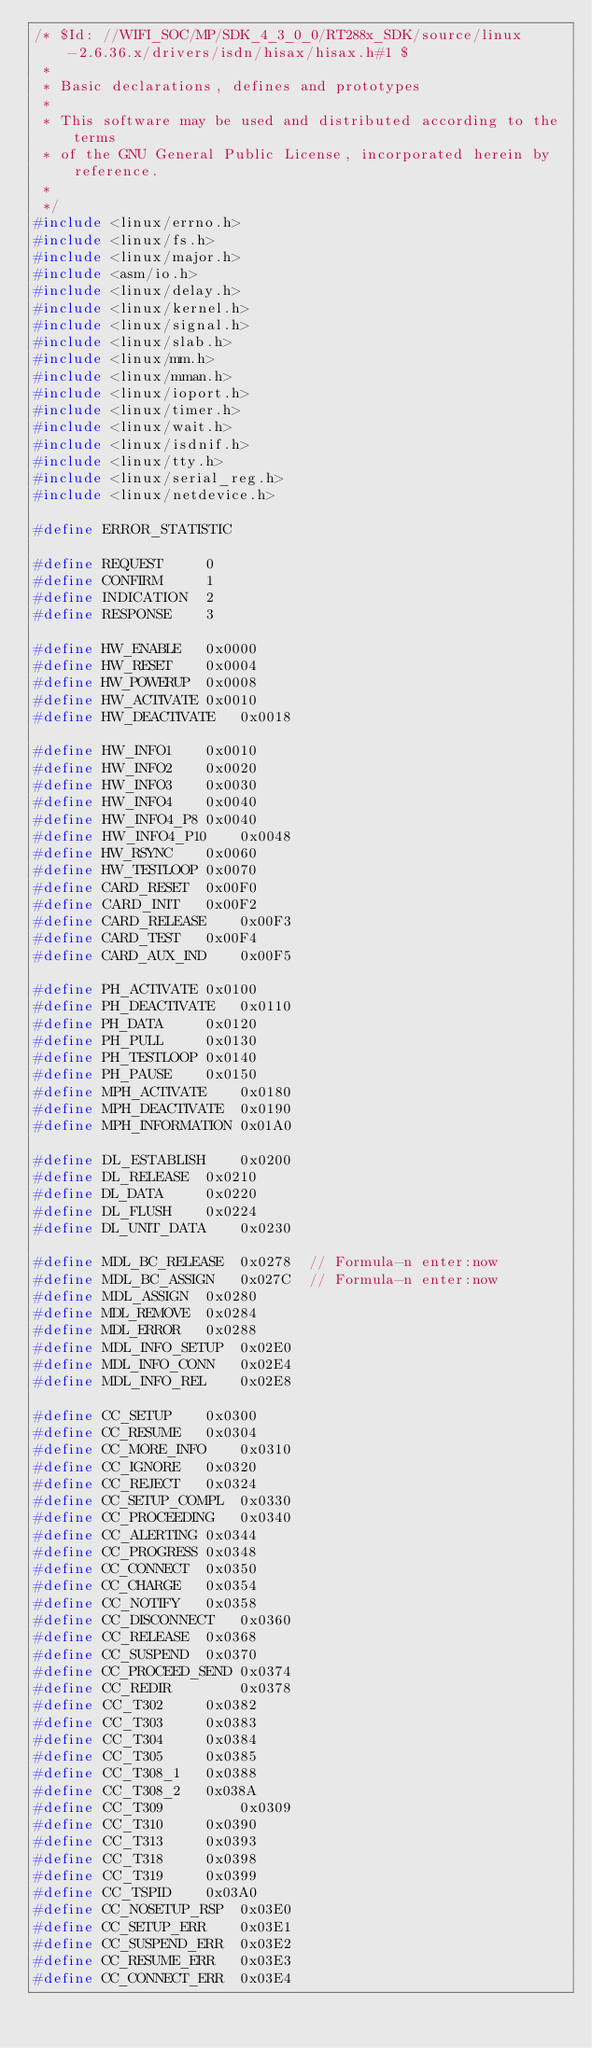<code> <loc_0><loc_0><loc_500><loc_500><_C_>/* $Id: //WIFI_SOC/MP/SDK_4_3_0_0/RT288x_SDK/source/linux-2.6.36.x/drivers/isdn/hisax/hisax.h#1 $
 *
 * Basic declarations, defines and prototypes
 *
 * This software may be used and distributed according to the terms
 * of the GNU General Public License, incorporated herein by reference.
 *
 */
#include <linux/errno.h>
#include <linux/fs.h>
#include <linux/major.h>
#include <asm/io.h>
#include <linux/delay.h>
#include <linux/kernel.h>
#include <linux/signal.h>
#include <linux/slab.h>
#include <linux/mm.h>
#include <linux/mman.h>
#include <linux/ioport.h>
#include <linux/timer.h>
#include <linux/wait.h>
#include <linux/isdnif.h>
#include <linux/tty.h>
#include <linux/serial_reg.h>
#include <linux/netdevice.h>

#define ERROR_STATISTIC

#define REQUEST		0
#define CONFIRM		1
#define INDICATION	2
#define RESPONSE	3

#define HW_ENABLE	0x0000
#define HW_RESET	0x0004
#define HW_POWERUP	0x0008
#define HW_ACTIVATE	0x0010
#define HW_DEACTIVATE	0x0018

#define HW_INFO1	0x0010
#define HW_INFO2	0x0020
#define HW_INFO3	0x0030
#define HW_INFO4	0x0040
#define HW_INFO4_P8	0x0040
#define HW_INFO4_P10	0x0048
#define HW_RSYNC	0x0060
#define HW_TESTLOOP	0x0070
#define CARD_RESET	0x00F0
#define CARD_INIT	0x00F2
#define CARD_RELEASE	0x00F3
#define CARD_TEST	0x00F4
#define CARD_AUX_IND	0x00F5

#define PH_ACTIVATE	0x0100
#define PH_DEACTIVATE	0x0110
#define PH_DATA		0x0120
#define PH_PULL		0x0130
#define PH_TESTLOOP	0x0140
#define PH_PAUSE	0x0150
#define MPH_ACTIVATE	0x0180
#define MPH_DEACTIVATE	0x0190
#define MPH_INFORMATION	0x01A0

#define DL_ESTABLISH	0x0200
#define DL_RELEASE	0x0210
#define DL_DATA		0x0220
#define DL_FLUSH	0x0224
#define DL_UNIT_DATA	0x0230

#define MDL_BC_RELEASE  0x0278  // Formula-n enter:now
#define MDL_BC_ASSIGN   0x027C  // Formula-n enter:now
#define MDL_ASSIGN	0x0280
#define MDL_REMOVE	0x0284
#define MDL_ERROR	0x0288
#define MDL_INFO_SETUP	0x02E0
#define MDL_INFO_CONN	0x02E4
#define MDL_INFO_REL	0x02E8

#define CC_SETUP	0x0300
#define CC_RESUME	0x0304
#define CC_MORE_INFO	0x0310
#define CC_IGNORE	0x0320
#define CC_REJECT	0x0324
#define CC_SETUP_COMPL	0x0330
#define CC_PROCEEDING	0x0340
#define CC_ALERTING	0x0344
#define CC_PROGRESS	0x0348
#define CC_CONNECT	0x0350
#define CC_CHARGE	0x0354
#define CC_NOTIFY	0x0358
#define CC_DISCONNECT	0x0360
#define CC_RELEASE	0x0368
#define CC_SUSPEND	0x0370
#define CC_PROCEED_SEND 0x0374
#define CC_REDIR        0x0378
#define CC_T302		0x0382
#define CC_T303		0x0383
#define CC_T304		0x0384
#define CC_T305		0x0385
#define CC_T308_1	0x0388
#define CC_T308_2	0x038A
#define CC_T309         0x0309
#define CC_T310		0x0390
#define CC_T313		0x0393
#define CC_T318		0x0398
#define CC_T319		0x0399
#define CC_TSPID	0x03A0
#define CC_NOSETUP_RSP	0x03E0
#define CC_SETUP_ERR	0x03E1
#define CC_SUSPEND_ERR	0x03E2
#define CC_RESUME_ERR	0x03E3
#define CC_CONNECT_ERR	0x03E4</code> 